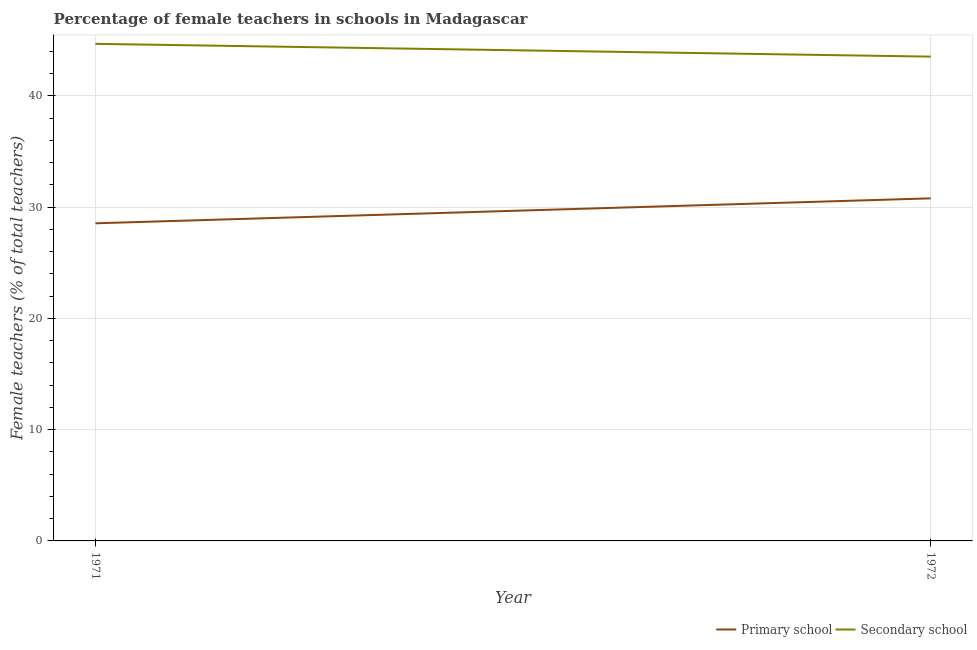How many different coloured lines are there?
Make the answer very short. 2. Does the line corresponding to percentage of female teachers in primary schools intersect with the line corresponding to percentage of female teachers in secondary schools?
Your answer should be very brief. No. What is the percentage of female teachers in primary schools in 1971?
Keep it short and to the point. 28.54. Across all years, what is the maximum percentage of female teachers in secondary schools?
Offer a terse response. 44.67. Across all years, what is the minimum percentage of female teachers in secondary schools?
Offer a very short reply. 43.52. What is the total percentage of female teachers in primary schools in the graph?
Your answer should be very brief. 59.33. What is the difference between the percentage of female teachers in primary schools in 1971 and that in 1972?
Keep it short and to the point. -2.24. What is the difference between the percentage of female teachers in secondary schools in 1972 and the percentage of female teachers in primary schools in 1971?
Give a very brief answer. 14.98. What is the average percentage of female teachers in primary schools per year?
Keep it short and to the point. 29.66. In the year 1971, what is the difference between the percentage of female teachers in secondary schools and percentage of female teachers in primary schools?
Provide a succinct answer. 16.13. What is the ratio of the percentage of female teachers in secondary schools in 1971 to that in 1972?
Your answer should be compact. 1.03. Is the percentage of female teachers in secondary schools strictly less than the percentage of female teachers in primary schools over the years?
Keep it short and to the point. No. How many lines are there?
Keep it short and to the point. 2. Are the values on the major ticks of Y-axis written in scientific E-notation?
Provide a succinct answer. No. Does the graph contain any zero values?
Your response must be concise. No. How many legend labels are there?
Keep it short and to the point. 2. What is the title of the graph?
Make the answer very short. Percentage of female teachers in schools in Madagascar. What is the label or title of the X-axis?
Ensure brevity in your answer.  Year. What is the label or title of the Y-axis?
Offer a very short reply. Female teachers (% of total teachers). What is the Female teachers (% of total teachers) in Primary school in 1971?
Your answer should be very brief. 28.54. What is the Female teachers (% of total teachers) of Secondary school in 1971?
Keep it short and to the point. 44.67. What is the Female teachers (% of total teachers) of Primary school in 1972?
Provide a short and direct response. 30.79. What is the Female teachers (% of total teachers) of Secondary school in 1972?
Offer a very short reply. 43.52. Across all years, what is the maximum Female teachers (% of total teachers) of Primary school?
Offer a terse response. 30.79. Across all years, what is the maximum Female teachers (% of total teachers) of Secondary school?
Provide a succinct answer. 44.67. Across all years, what is the minimum Female teachers (% of total teachers) of Primary school?
Your response must be concise. 28.54. Across all years, what is the minimum Female teachers (% of total teachers) in Secondary school?
Offer a very short reply. 43.52. What is the total Female teachers (% of total teachers) in Primary school in the graph?
Give a very brief answer. 59.33. What is the total Female teachers (% of total teachers) in Secondary school in the graph?
Ensure brevity in your answer.  88.19. What is the difference between the Female teachers (% of total teachers) of Primary school in 1971 and that in 1972?
Provide a short and direct response. -2.24. What is the difference between the Female teachers (% of total teachers) of Secondary school in 1971 and that in 1972?
Offer a terse response. 1.15. What is the difference between the Female teachers (% of total teachers) of Primary school in 1971 and the Female teachers (% of total teachers) of Secondary school in 1972?
Your answer should be compact. -14.98. What is the average Female teachers (% of total teachers) of Primary school per year?
Your response must be concise. 29.66. What is the average Female teachers (% of total teachers) of Secondary school per year?
Make the answer very short. 44.1. In the year 1971, what is the difference between the Female teachers (% of total teachers) in Primary school and Female teachers (% of total teachers) in Secondary school?
Keep it short and to the point. -16.13. In the year 1972, what is the difference between the Female teachers (% of total teachers) of Primary school and Female teachers (% of total teachers) of Secondary school?
Provide a short and direct response. -12.74. What is the ratio of the Female teachers (% of total teachers) in Primary school in 1971 to that in 1972?
Make the answer very short. 0.93. What is the ratio of the Female teachers (% of total teachers) of Secondary school in 1971 to that in 1972?
Make the answer very short. 1.03. What is the difference between the highest and the second highest Female teachers (% of total teachers) of Primary school?
Offer a very short reply. 2.24. What is the difference between the highest and the second highest Female teachers (% of total teachers) of Secondary school?
Your response must be concise. 1.15. What is the difference between the highest and the lowest Female teachers (% of total teachers) in Primary school?
Your response must be concise. 2.24. What is the difference between the highest and the lowest Female teachers (% of total teachers) of Secondary school?
Keep it short and to the point. 1.15. 